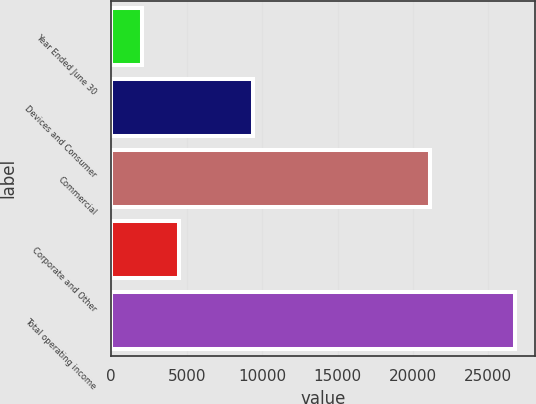<chart> <loc_0><loc_0><loc_500><loc_500><bar_chart><fcel>Year Ended June 30<fcel>Devices and Consumer<fcel>Commercial<fcel>Corporate and Other<fcel>Total operating income<nl><fcel>2013<fcel>9421<fcel>21132<fcel>4488.1<fcel>26764<nl></chart> 